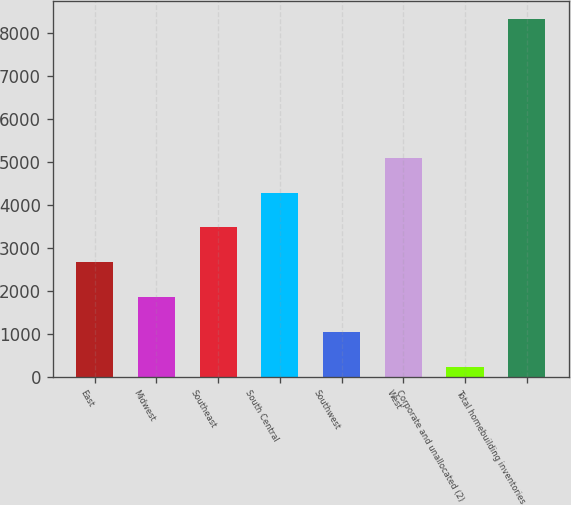Convert chart to OTSL. <chart><loc_0><loc_0><loc_500><loc_500><bar_chart><fcel>East<fcel>Midwest<fcel>Southeast<fcel>South Central<fcel>Southwest<fcel>West<fcel>Corporate and unallocated (2)<fcel>Total homebuilding inventories<nl><fcel>2673.07<fcel>1863.38<fcel>3482.76<fcel>4292.45<fcel>1053.69<fcel>5102.14<fcel>244<fcel>8340.9<nl></chart> 